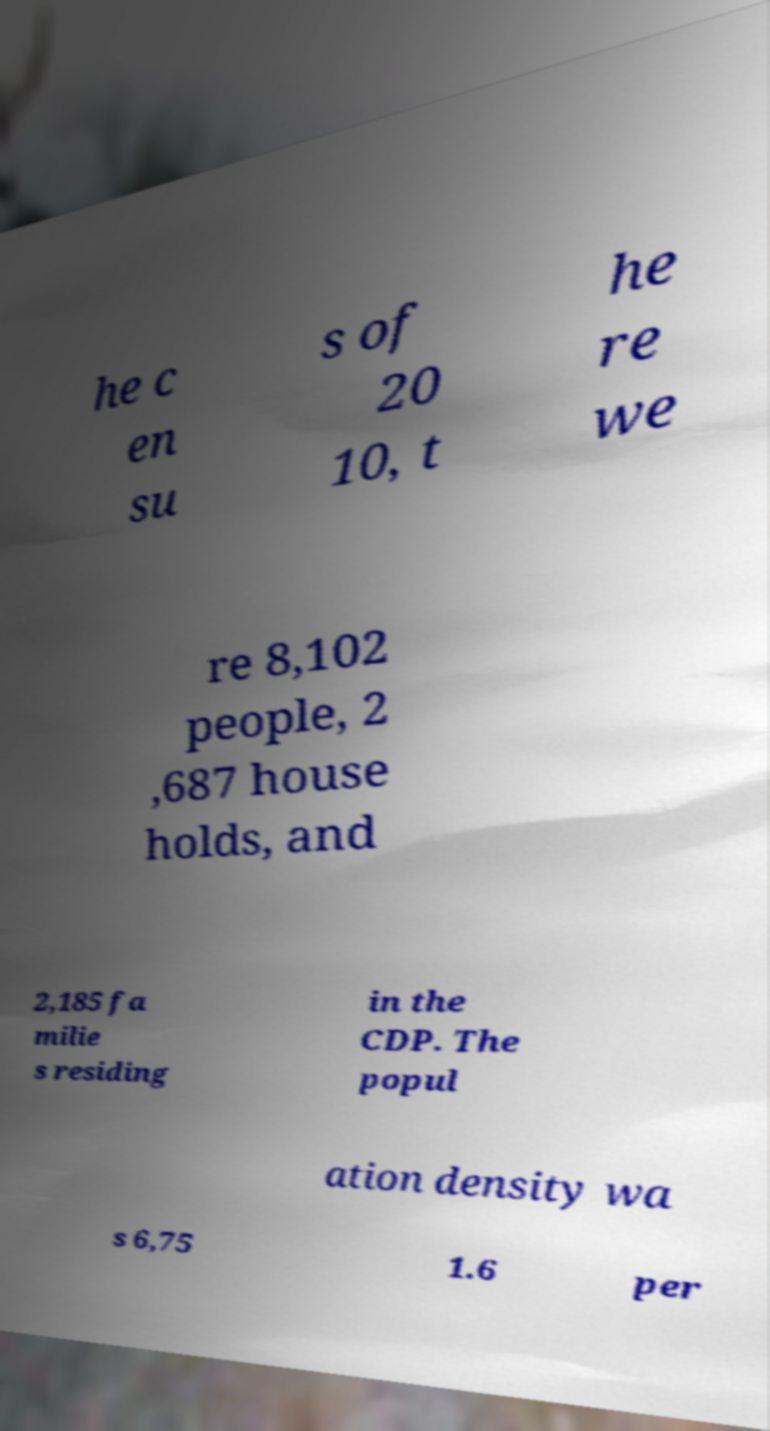Please identify and transcribe the text found in this image. he c en su s of 20 10, t he re we re 8,102 people, 2 ,687 house holds, and 2,185 fa milie s residing in the CDP. The popul ation density wa s 6,75 1.6 per 